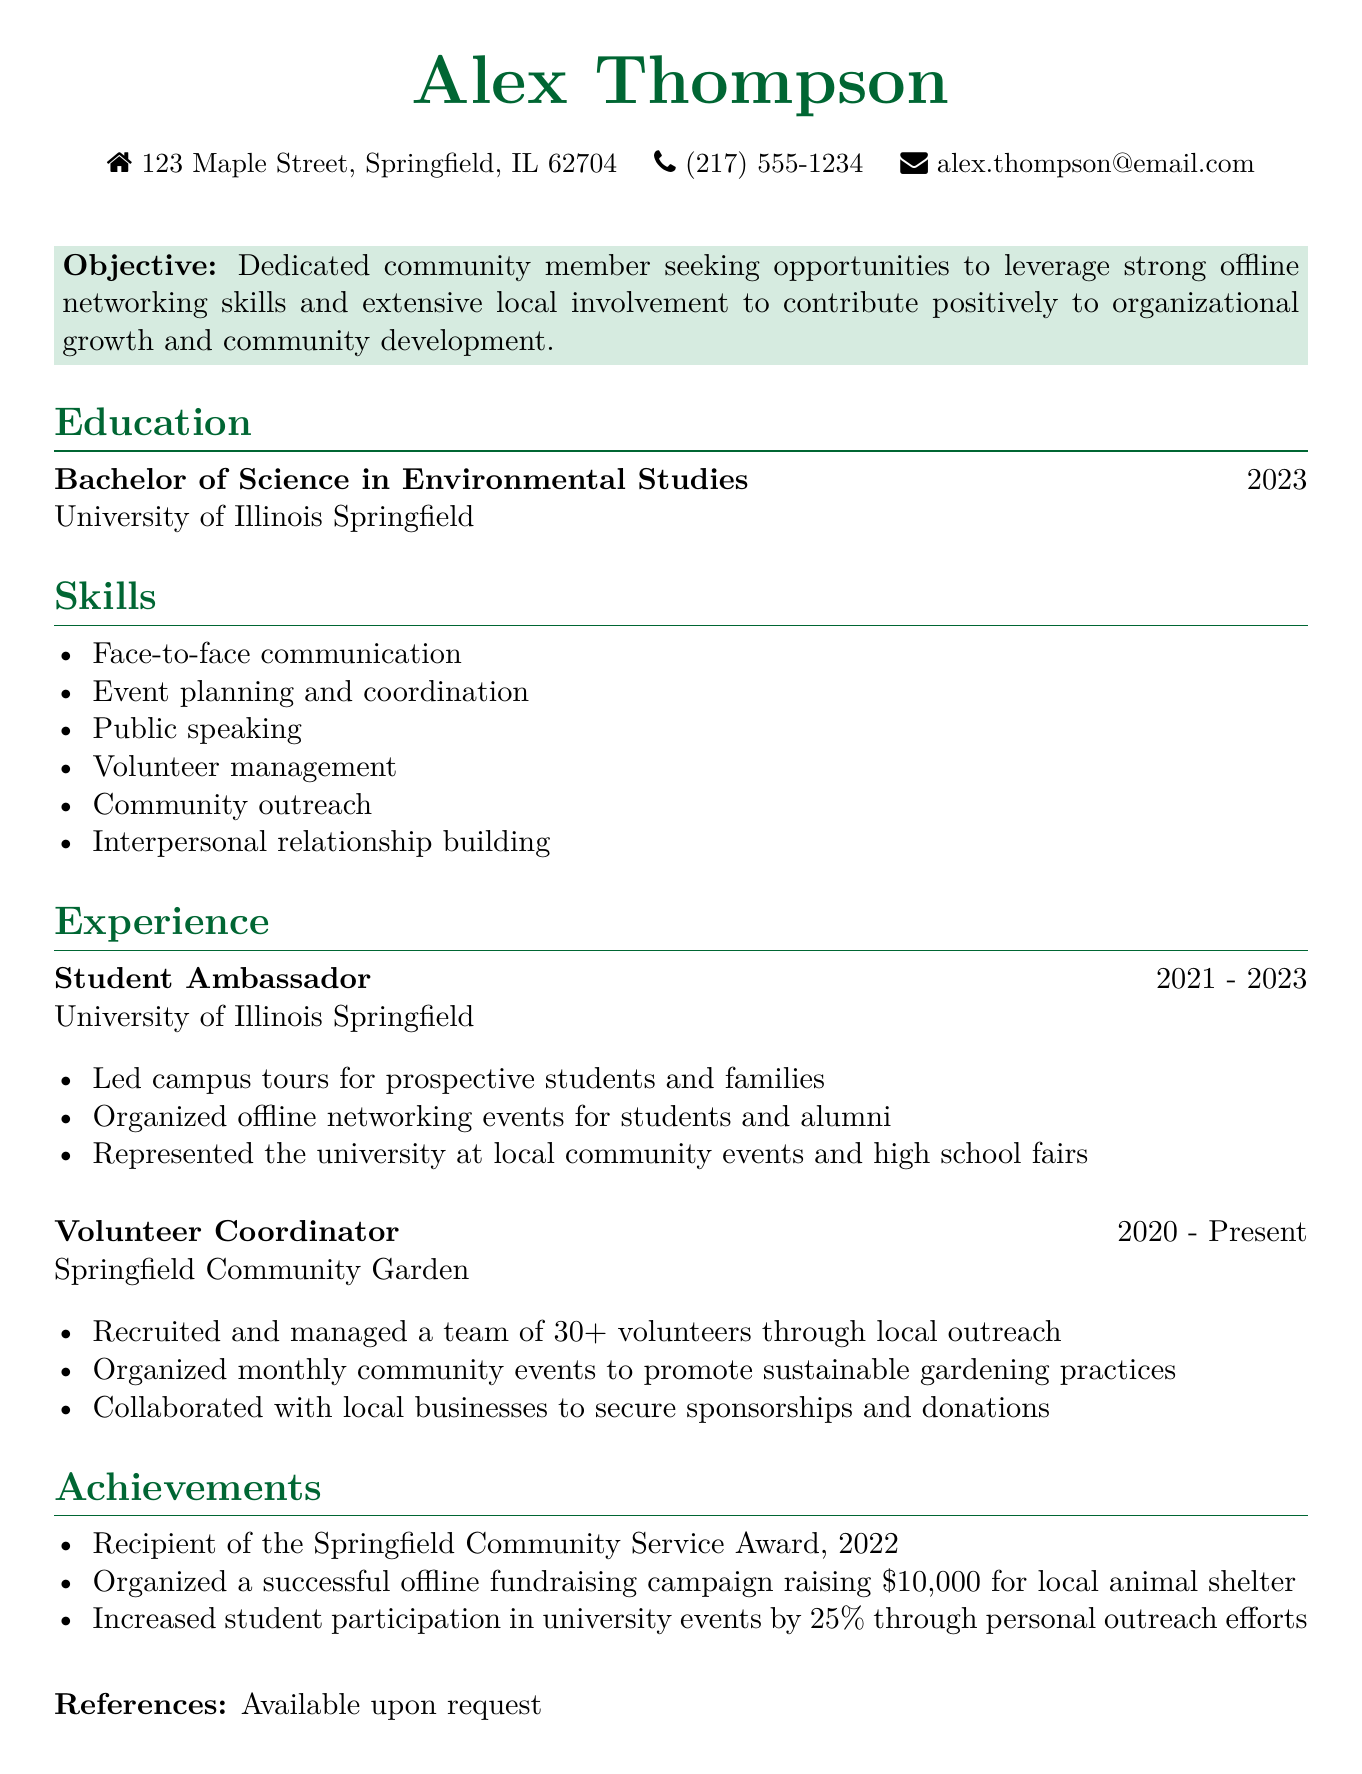What is the name of the individual? The name is presented at the top of the document.
Answer: Alex Thompson What degree did Alex earn? The degree is listed in the education section of the document.
Answer: Bachelor of Science in Environmental Studies What year did Alex graduate? The graduation year follows the degree in the education section.
Answer: 2023 What is Alex's role at the Springfield Community Garden? The title is mentioned in the experience section of the document.
Answer: Volunteer Coordinator How many volunteers did Alex manage at the Springfield Community Garden? This information is found in the responsibilities under the Volunteer Coordinator experience.
Answer: 30+ What type of event did Alex organize to raise funds for the local animal shelter? The achievement section highlights the specific activity organized by Alex.
Answer: Offline fundraising campaign What award did Alex receive in 2022? This is listed in the achievements section of the document.
Answer: Springfield Community Service Award How much money was raised in the offline fundraising campaign? The specific amount is noted under achievements.
Answer: $10,000 What is the key objective stated in Alex's CV? The objective is summarized at the beginning of the document.
Answer: Contribute positively to organizational growth and community development 